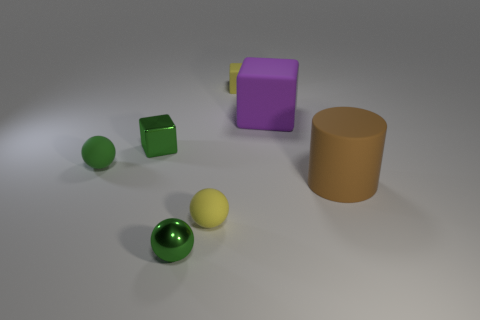Add 2 big objects. How many objects exist? 9 Subtract all cylinders. How many objects are left? 6 Add 2 matte things. How many matte things exist? 7 Subtract 0 red balls. How many objects are left? 7 Subtract all small shiny cubes. Subtract all large cyan matte objects. How many objects are left? 6 Add 7 metallic balls. How many metallic balls are left? 8 